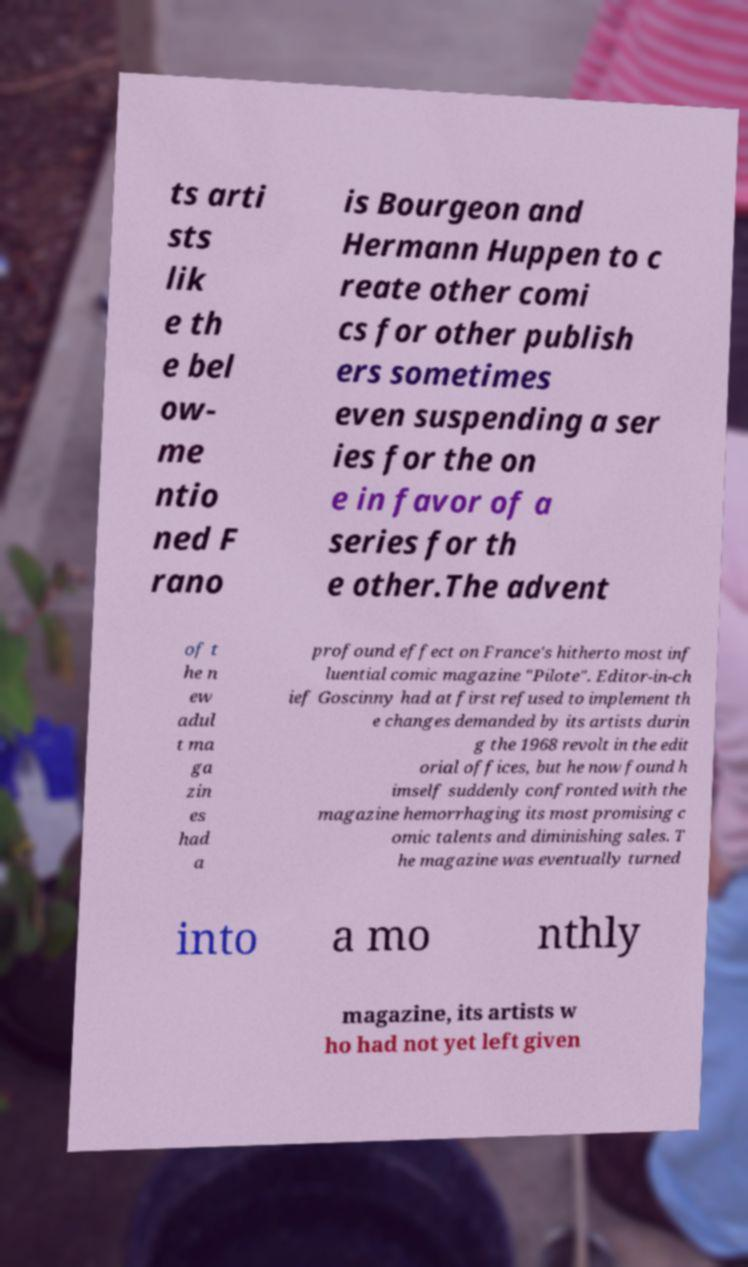Could you extract and type out the text from this image? ts arti sts lik e th e bel ow- me ntio ned F rano is Bourgeon and Hermann Huppen to c reate other comi cs for other publish ers sometimes even suspending a ser ies for the on e in favor of a series for th e other.The advent of t he n ew adul t ma ga zin es had a profound effect on France's hitherto most inf luential comic magazine "Pilote". Editor-in-ch ief Goscinny had at first refused to implement th e changes demanded by its artists durin g the 1968 revolt in the edit orial offices, but he now found h imself suddenly confronted with the magazine hemorrhaging its most promising c omic talents and diminishing sales. T he magazine was eventually turned into a mo nthly magazine, its artists w ho had not yet left given 